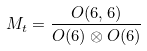<formula> <loc_0><loc_0><loc_500><loc_500>M _ { t } = \frac { O ( 6 , 6 ) } { O ( 6 ) \otimes O ( 6 ) }</formula> 